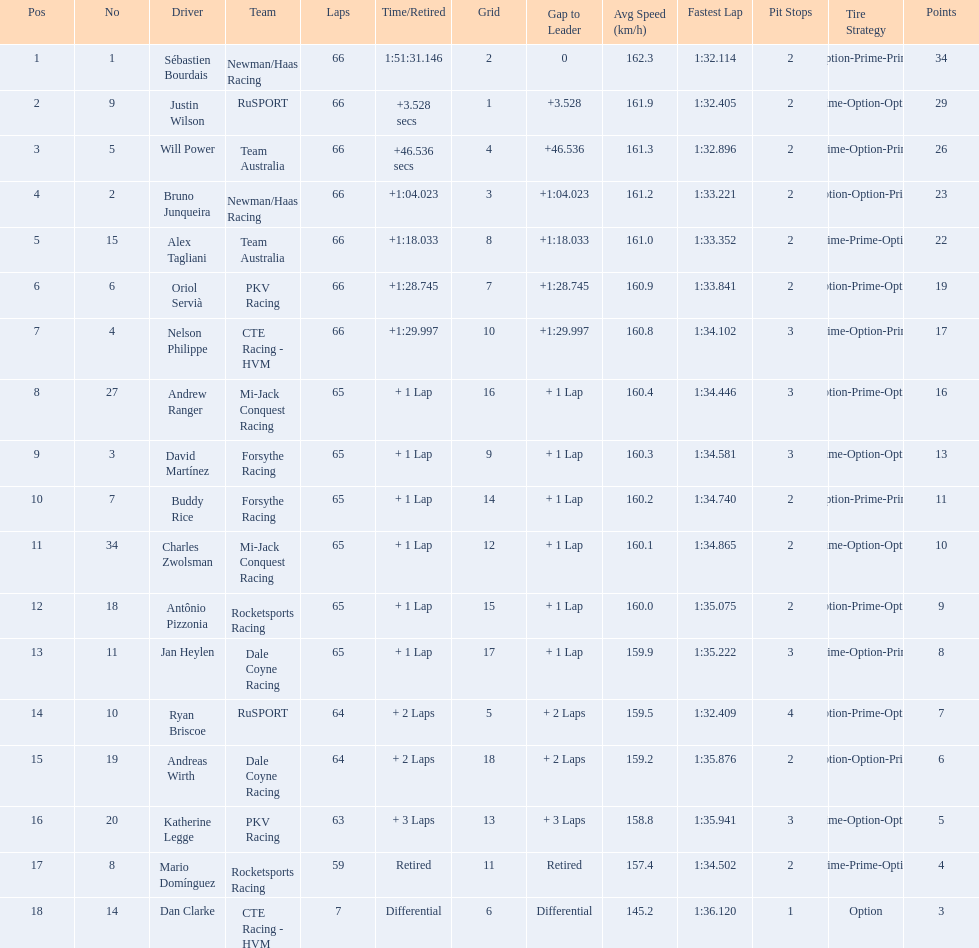At the 2006 gran premio telmex, did oriol servia or katherine legge complete more laps? Oriol Servià. 